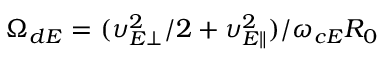<formula> <loc_0><loc_0><loc_500><loc_500>\Omega _ { d E } = ( \upsilon _ { E \perp } ^ { 2 } / 2 + \upsilon _ { E \| } ^ { 2 } ) / \omega _ { c E } R _ { 0 }</formula> 